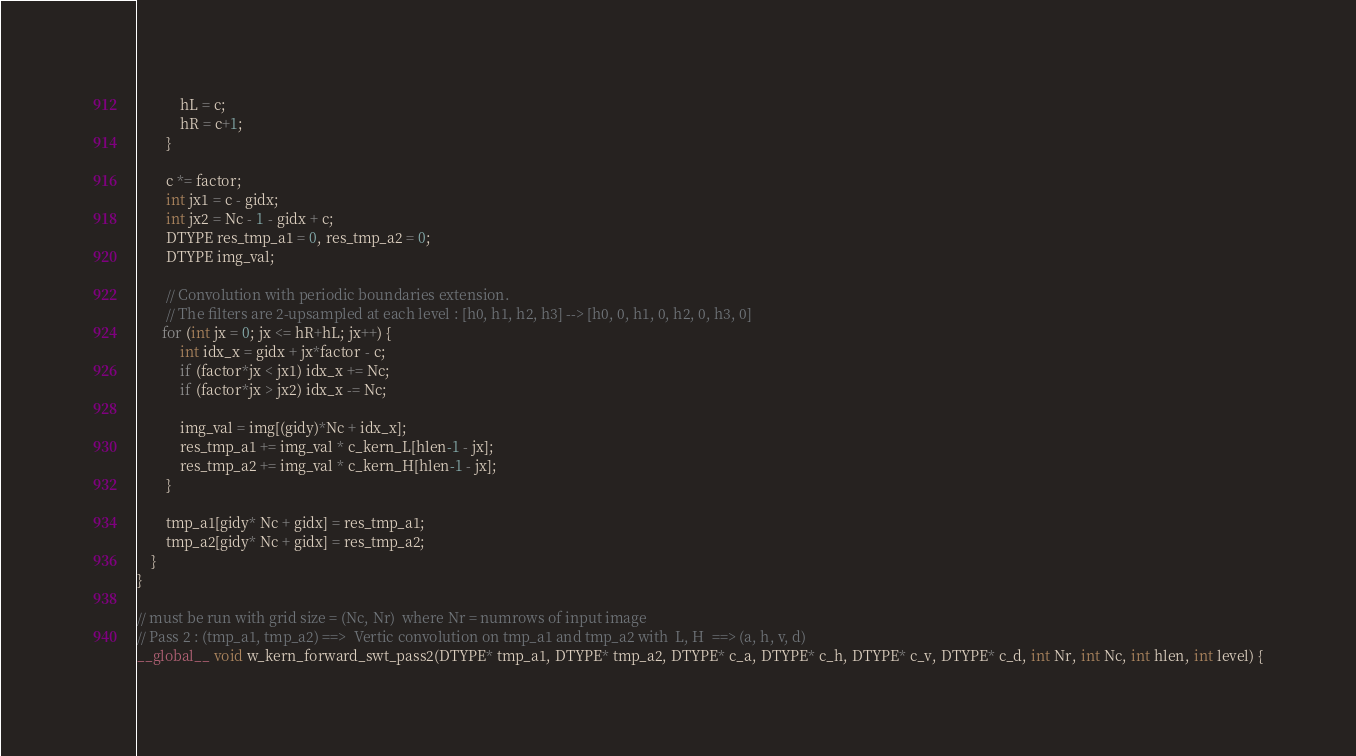<code> <loc_0><loc_0><loc_500><loc_500><_Cuda_>            hL = c;
            hR = c+1;
        }

        c *= factor;
        int jx1 = c - gidx;
        int jx2 = Nc - 1 - gidx + c;
        DTYPE res_tmp_a1 = 0, res_tmp_a2 = 0;
        DTYPE img_val;

        // Convolution with periodic boundaries extension.
        // The filters are 2-upsampled at each level : [h0, h1, h2, h3] --> [h0, 0, h1, 0, h2, 0, h3, 0]
       for (int jx = 0; jx <= hR+hL; jx++) {
            int idx_x = gidx + jx*factor - c;
            if (factor*jx < jx1) idx_x += Nc;
            if (factor*jx > jx2) idx_x -= Nc;

            img_val = img[(gidy)*Nc + idx_x];
            res_tmp_a1 += img_val * c_kern_L[hlen-1 - jx];
            res_tmp_a2 += img_val * c_kern_H[hlen-1 - jx];
        }

        tmp_a1[gidy* Nc + gidx] = res_tmp_a1;
        tmp_a2[gidy* Nc + gidx] = res_tmp_a2;
    }
}

// must be run with grid size = (Nc, Nr)  where Nr = numrows of input image
// Pass 2 : (tmp_a1, tmp_a2) ==>  Vertic convolution on tmp_a1 and tmp_a2 with  L, H  ==> (a, h, v, d)
__global__ void w_kern_forward_swt_pass2(DTYPE* tmp_a1, DTYPE* tmp_a2, DTYPE* c_a, DTYPE* c_h, DTYPE* c_v, DTYPE* c_d, int Nr, int Nc, int hlen, int level) {</code> 